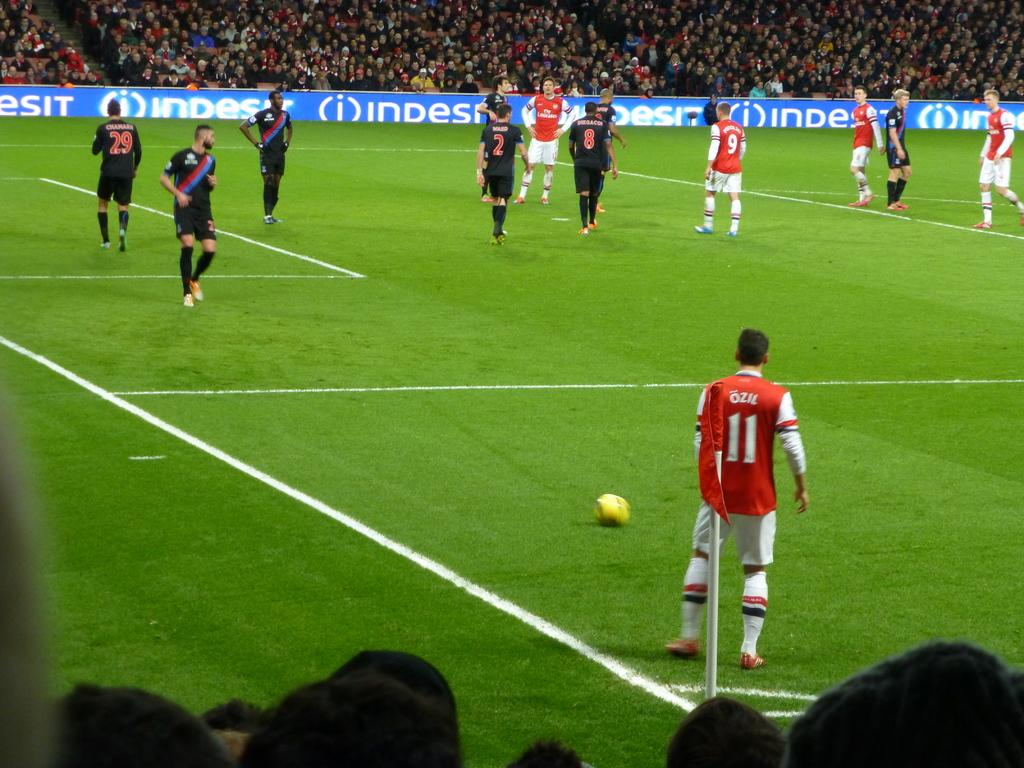Provide a one-sentence caption for the provided image. A soccer match with players standing on the green in front of ads for INDESIT. 